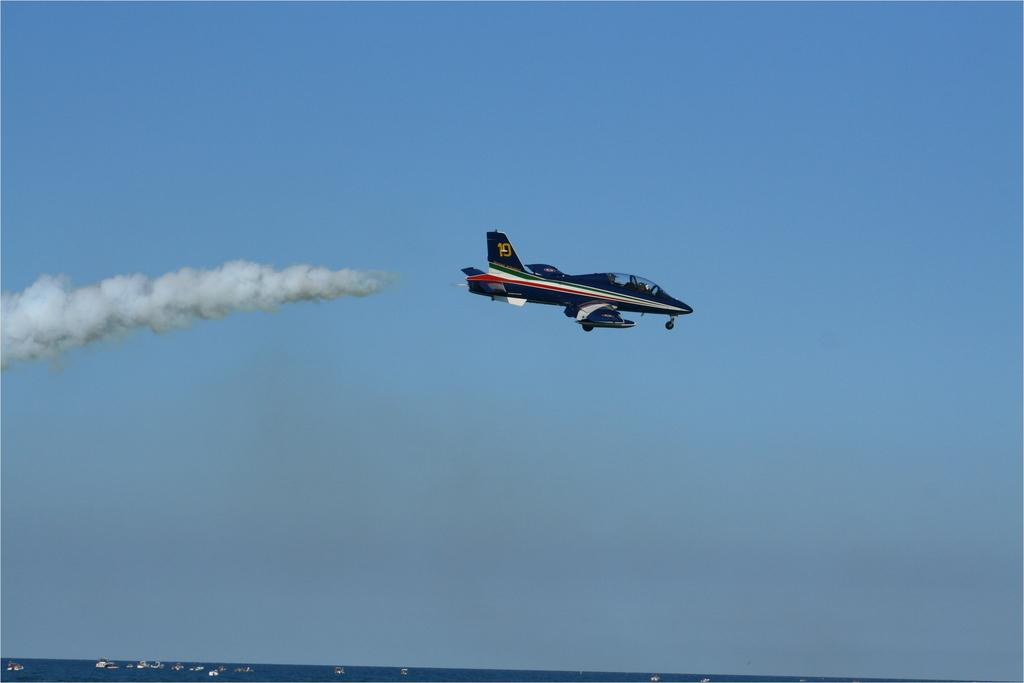What is flying in the air in the image? There is a helicopter in the air in the image. What is the helicopter doing in the image? The helicopter is producing smoke in the image. What can be seen at the bottom of the image? There are ships visible at the bottom of the image. Where are the ships located in relation to the water? The ships are on a river in the image. What type of tray is being used to carry the pump in the image? There is no tray or pump present in the image. 